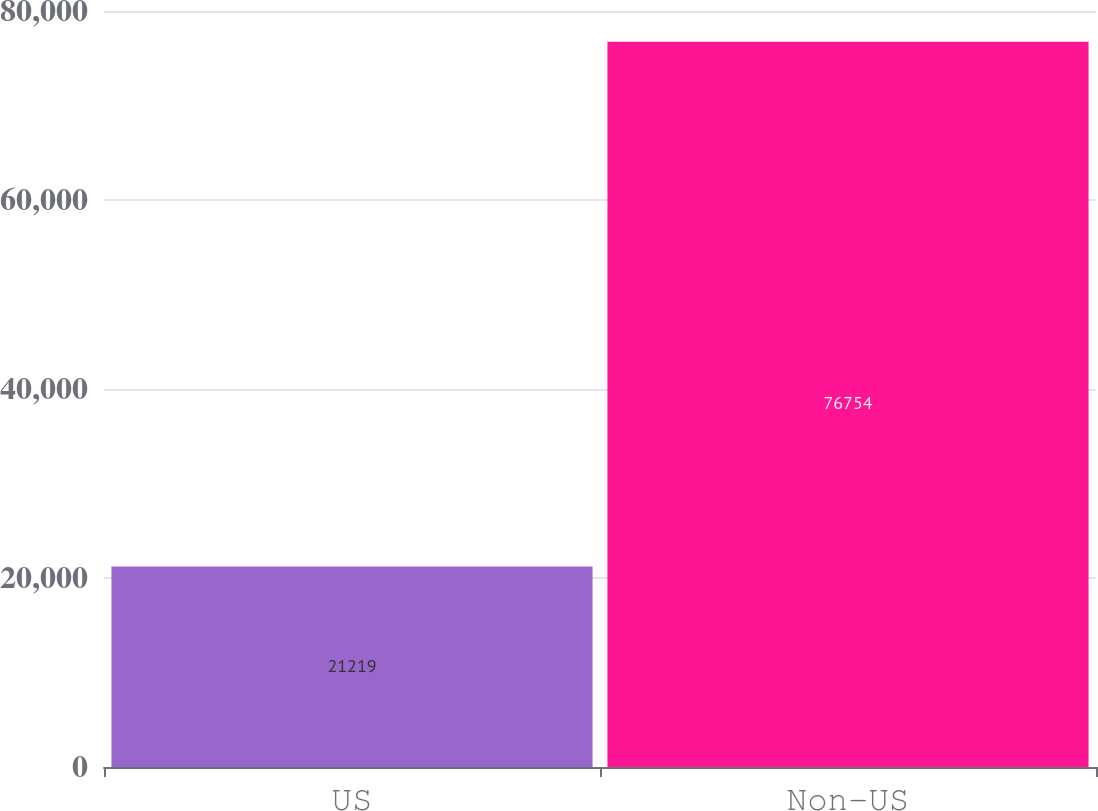<chart> <loc_0><loc_0><loc_500><loc_500><bar_chart><fcel>US<fcel>Non-US<nl><fcel>21219<fcel>76754<nl></chart> 